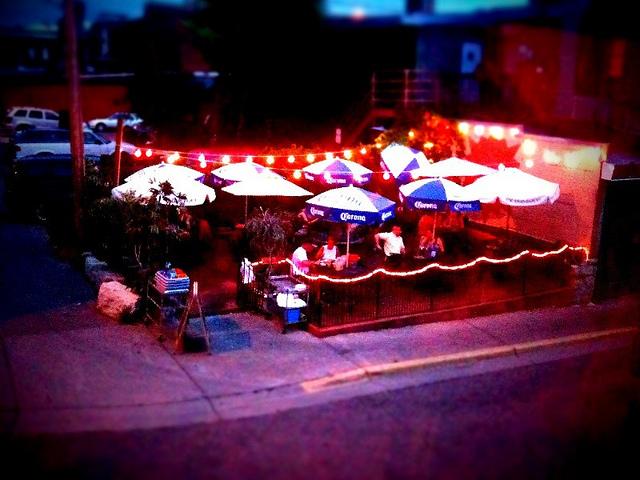How many umbrellas are in this picture?
Write a very short answer. 10. What shape do the lights make?
Be succinct. Circles. Is this a outdoors nightclub?
Answer briefly. No. What beer brand is on the umbrella?
Write a very short answer. Corona. Where is the light source in this photo?
Short answer required. Above tables. Is this place lit up?
Write a very short answer. Yes. 